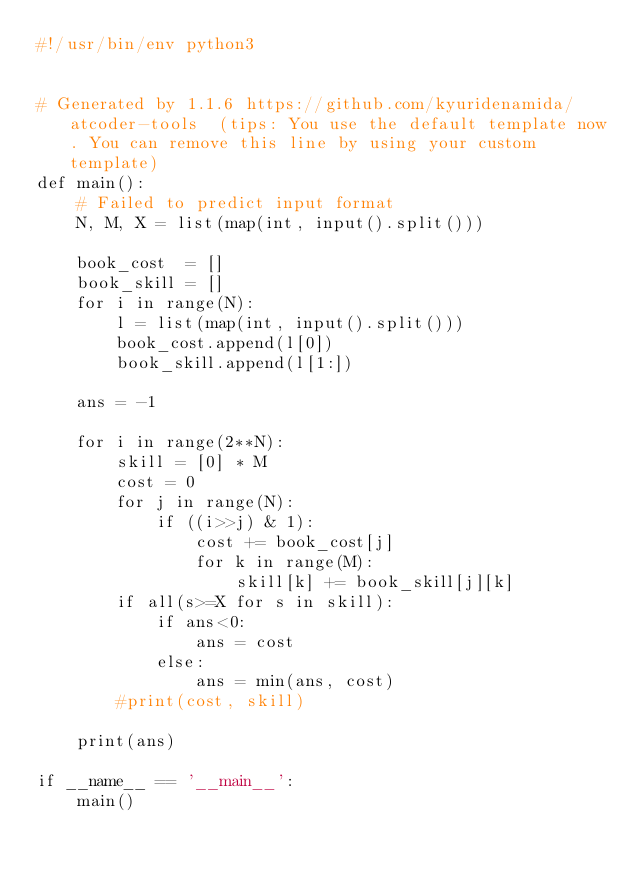Convert code to text. <code><loc_0><loc_0><loc_500><loc_500><_Python_>#!/usr/bin/env python3


# Generated by 1.1.6 https://github.com/kyuridenamida/atcoder-tools  (tips: You use the default template now. You can remove this line by using your custom template)
def main():
    # Failed to predict input format
    N, M, X = list(map(int, input().split()))

    book_cost  = []
    book_skill = []
    for i in range(N):
        l = list(map(int, input().split()))
        book_cost.append(l[0])
        book_skill.append(l[1:])

    ans = -1

    for i in range(2**N):
        skill = [0] * M
        cost = 0
        for j in range(N):
            if ((i>>j) & 1):
                cost += book_cost[j]
                for k in range(M):
                    skill[k] += book_skill[j][k]
        if all(s>=X for s in skill):
            if ans<0:
                ans = cost
            else:
                ans = min(ans, cost)
        #print(cost, skill)

    print(ans)

if __name__ == '__main__':
    main()
</code> 